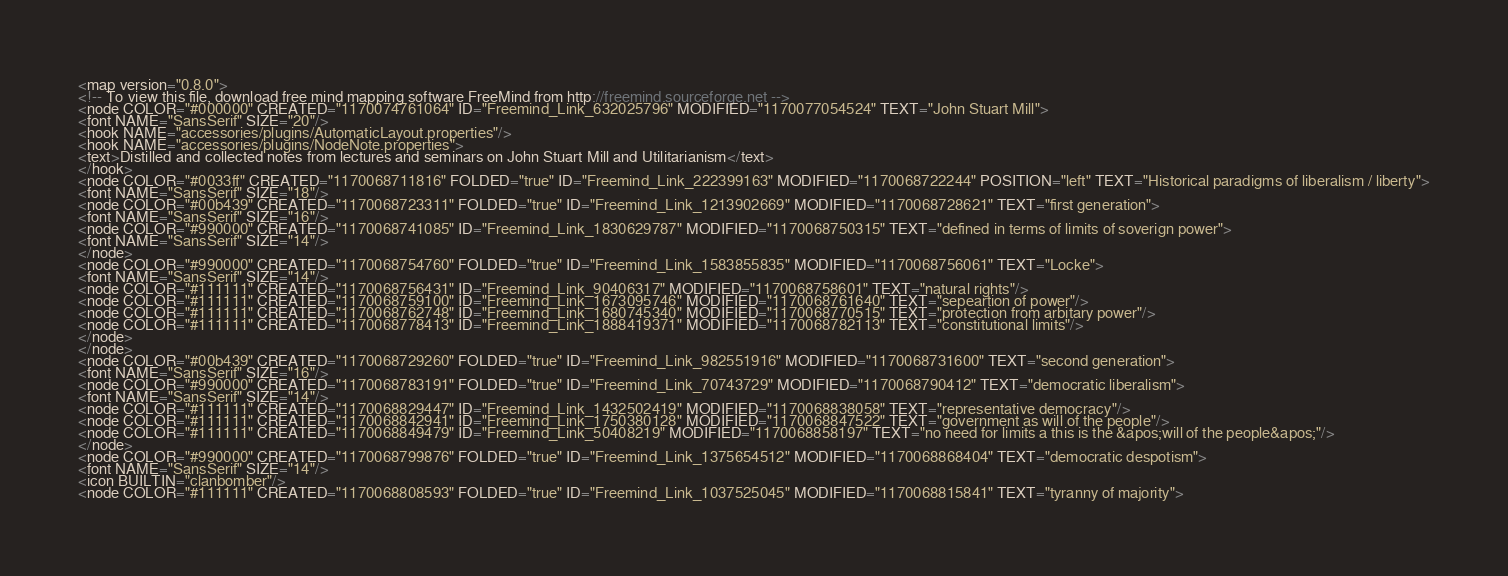Convert code to text. <code><loc_0><loc_0><loc_500><loc_500><_ObjectiveC_><map version="0.8.0">
<!-- To view this file, download free mind mapping software FreeMind from http://freemind.sourceforge.net -->
<node COLOR="#000000" CREATED="1170074761064" ID="Freemind_Link_632025796" MODIFIED="1170077054524" TEXT="John Stuart Mill">
<font NAME="SansSerif" SIZE="20"/>
<hook NAME="accessories/plugins/AutomaticLayout.properties"/>
<hook NAME="accessories/plugins/NodeNote.properties">
<text>Distilled and collected notes from lectures and seminars on John Stuart Mill and Utilitarianism</text>
</hook>
<node COLOR="#0033ff" CREATED="1170068711816" FOLDED="true" ID="Freemind_Link_222399163" MODIFIED="1170068722244" POSITION="left" TEXT="Historical paradigms of liberalism / liberty">
<font NAME="SansSerif" SIZE="18"/>
<node COLOR="#00b439" CREATED="1170068723311" FOLDED="true" ID="Freemind_Link_1213902669" MODIFIED="1170068728621" TEXT="first generation">
<font NAME="SansSerif" SIZE="16"/>
<node COLOR="#990000" CREATED="1170068741085" ID="Freemind_Link_1830629787" MODIFIED="1170068750315" TEXT="defined in terms of limits of soverign power">
<font NAME="SansSerif" SIZE="14"/>
</node>
<node COLOR="#990000" CREATED="1170068754760" FOLDED="true" ID="Freemind_Link_1583855835" MODIFIED="1170068756061" TEXT="Locke">
<font NAME="SansSerif" SIZE="14"/>
<node COLOR="#111111" CREATED="1170068756431" ID="Freemind_Link_90406317" MODIFIED="1170068758601" TEXT="natural rights"/>
<node COLOR="#111111" CREATED="1170068759100" ID="Freemind_Link_1673095746" MODIFIED="1170068761640" TEXT="sepeartion of power"/>
<node COLOR="#111111" CREATED="1170068762748" ID="Freemind_Link_1680745340" MODIFIED="1170068770515" TEXT="protection from arbitary power"/>
<node COLOR="#111111" CREATED="1170068778413" ID="Freemind_Link_1888419371" MODIFIED="1170068782113" TEXT="constitutional limits"/>
</node>
</node>
<node COLOR="#00b439" CREATED="1170068729260" FOLDED="true" ID="Freemind_Link_982551916" MODIFIED="1170068731600" TEXT="second generation">
<font NAME="SansSerif" SIZE="16"/>
<node COLOR="#990000" CREATED="1170068783191" FOLDED="true" ID="Freemind_Link_70743729" MODIFIED="1170068790412" TEXT="democratic liberalism">
<font NAME="SansSerif" SIZE="14"/>
<node COLOR="#111111" CREATED="1170068829447" ID="Freemind_Link_1432502419" MODIFIED="1170068838058" TEXT="representative democracy"/>
<node COLOR="#111111" CREATED="1170068842941" ID="Freemind_Link_1750380128" MODIFIED="1170068847522" TEXT="government as will of the people"/>
<node COLOR="#111111" CREATED="1170068849479" ID="Freemind_Link_50408219" MODIFIED="1170068858197" TEXT="no need for limits a this is the &apos;will of the people&apos;"/>
</node>
<node COLOR="#990000" CREATED="1170068799876" FOLDED="true" ID="Freemind_Link_1375654512" MODIFIED="1170068868404" TEXT="democratic despotism">
<font NAME="SansSerif" SIZE="14"/>
<icon BUILTIN="clanbomber"/>
<node COLOR="#111111" CREATED="1170068808593" FOLDED="true" ID="Freemind_Link_1037525045" MODIFIED="1170068815841" TEXT="tyranny of majority"></code> 